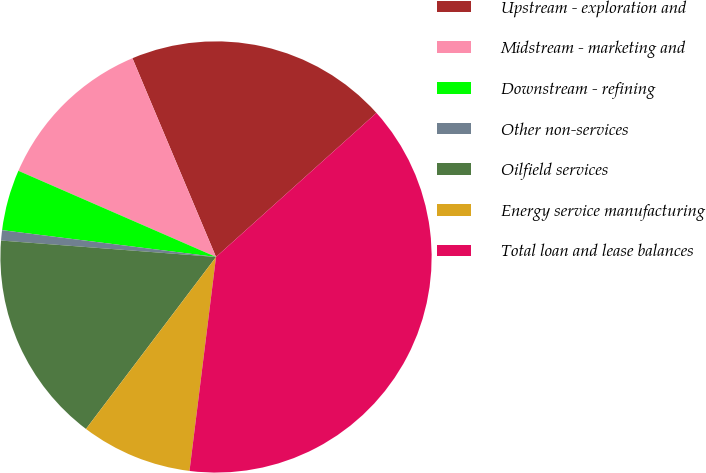<chart> <loc_0><loc_0><loc_500><loc_500><pie_chart><fcel>Upstream - exploration and<fcel>Midstream - marketing and<fcel>Downstream - refining<fcel>Other non-services<fcel>Oilfield services<fcel>Energy service manufacturing<fcel>Total loan and lease balances<nl><fcel>19.69%<fcel>12.12%<fcel>4.56%<fcel>0.77%<fcel>15.91%<fcel>8.34%<fcel>38.61%<nl></chart> 